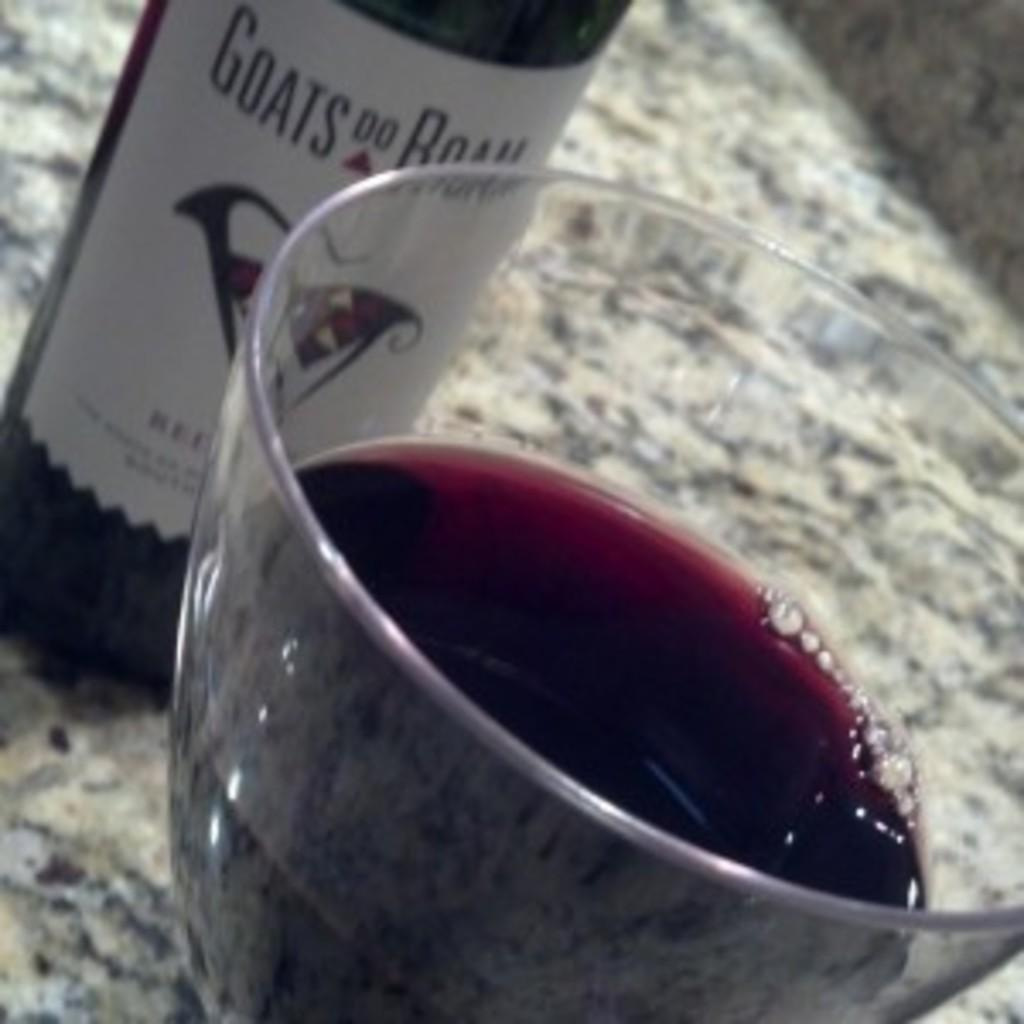<image>
Summarize the visual content of the image. A glass of wine and a bottle of Goats Do Roam are sitting on a granite counter top. 